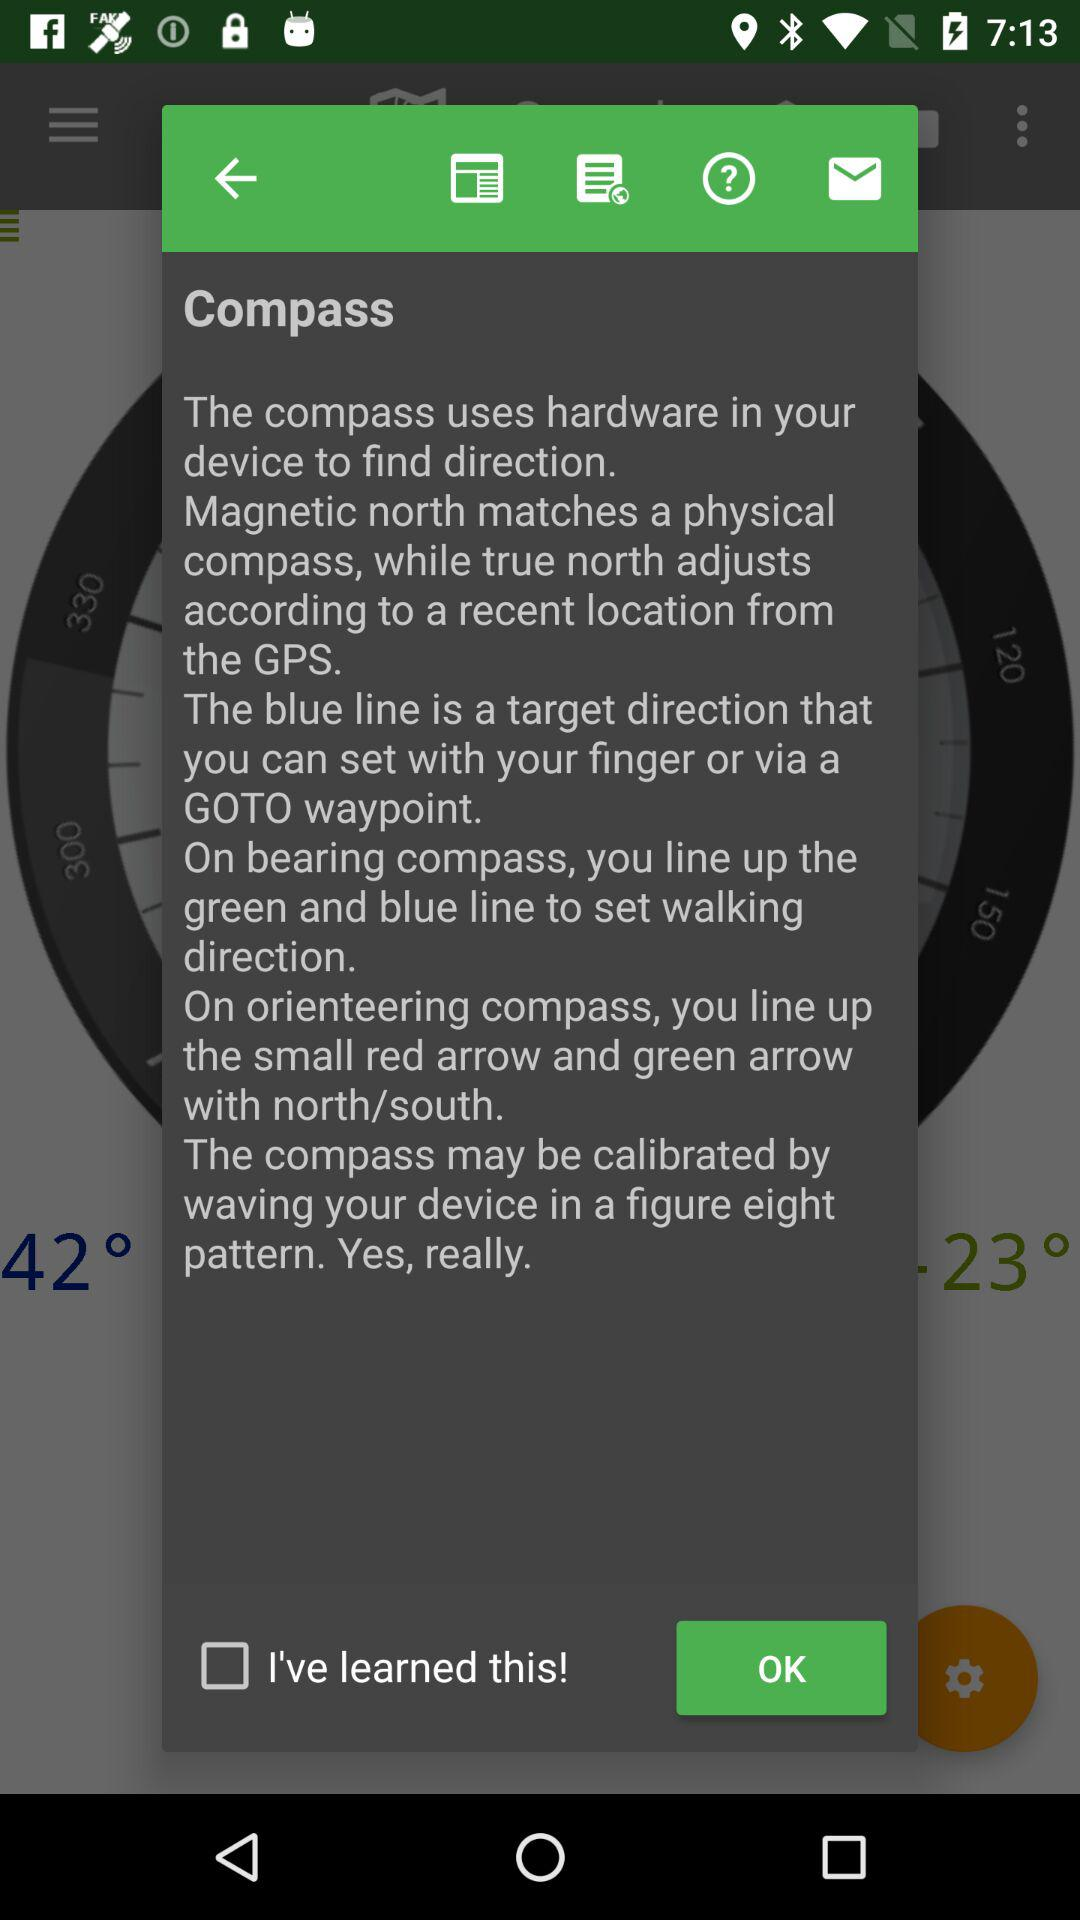Is "I've learned this!" checked or unchecked? "I've learned this!" is unchecked. 